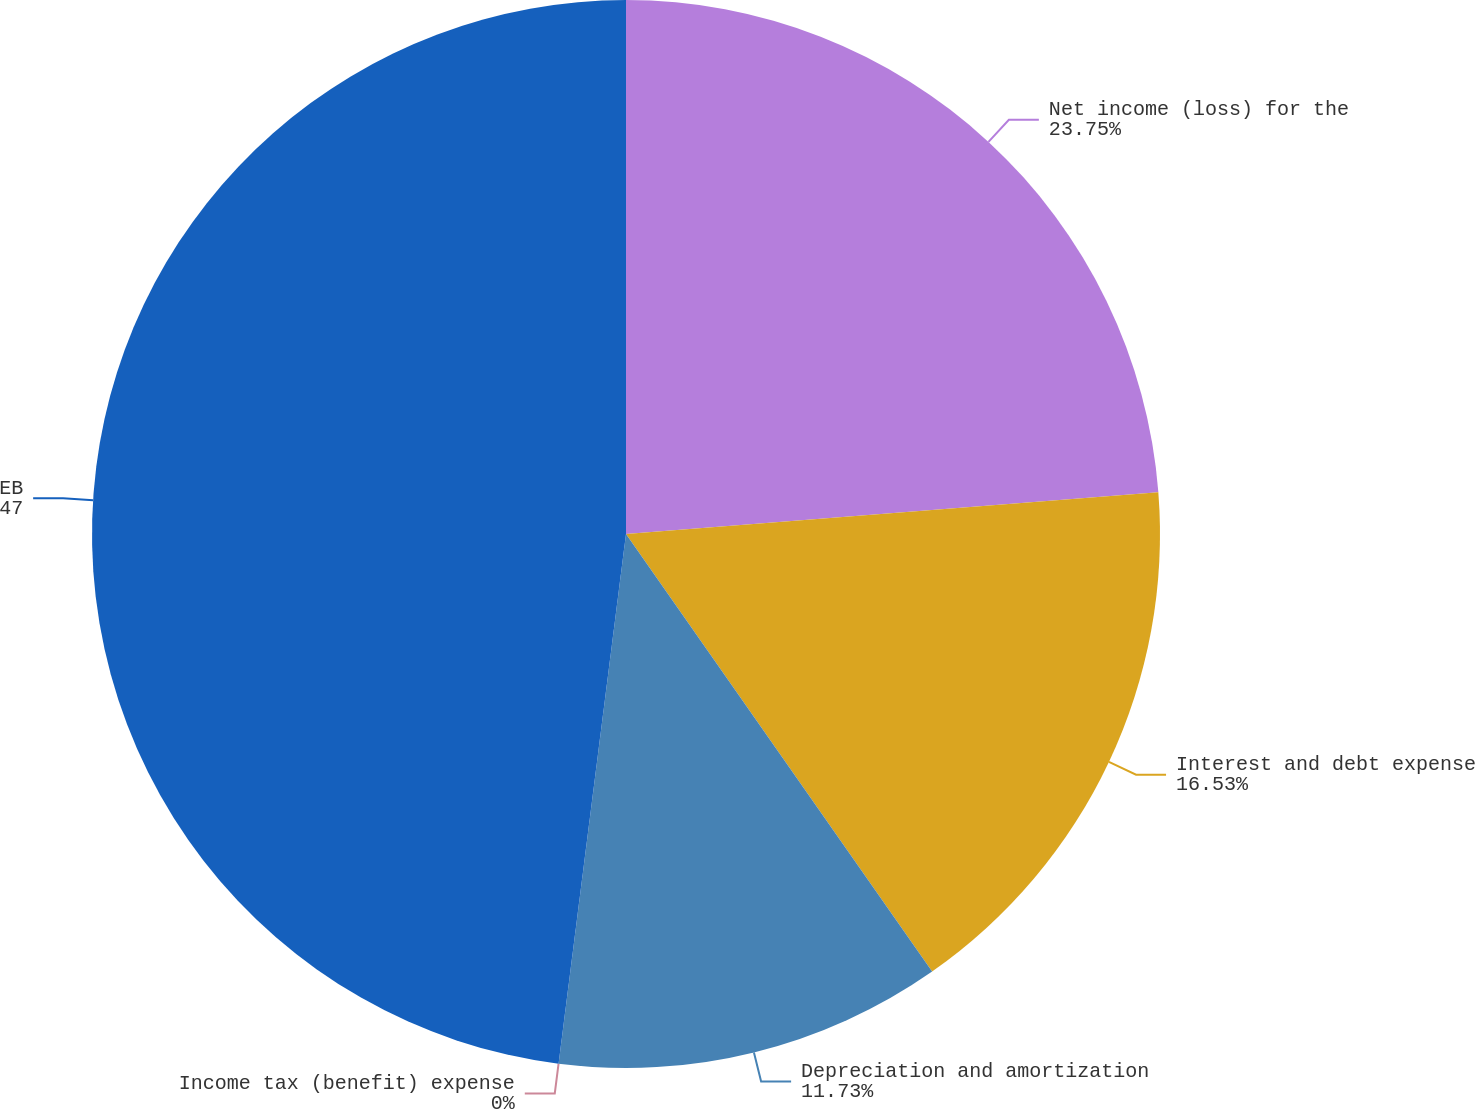Convert chart. <chart><loc_0><loc_0><loc_500><loc_500><pie_chart><fcel>Net income (loss) for the<fcel>Interest and debt expense<fcel>Depreciation and amortization<fcel>Income tax (benefit) expense<fcel>EBITDA for the three months<nl><fcel>23.75%<fcel>16.53%<fcel>11.73%<fcel>0.0%<fcel>47.98%<nl></chart> 